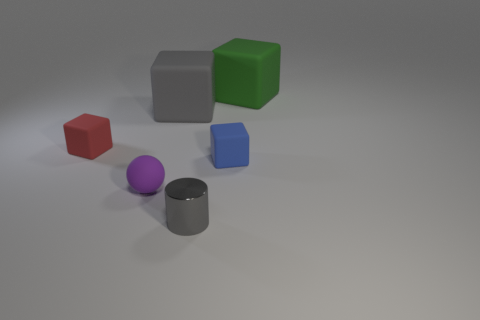Add 4 gray cubes. How many objects exist? 10 Subtract all spheres. How many objects are left? 5 Subtract 0 yellow cylinders. How many objects are left? 6 Subtract all tiny metal cylinders. Subtract all blue objects. How many objects are left? 4 Add 5 green matte things. How many green matte things are left? 6 Add 4 big red cylinders. How many big red cylinders exist? 4 